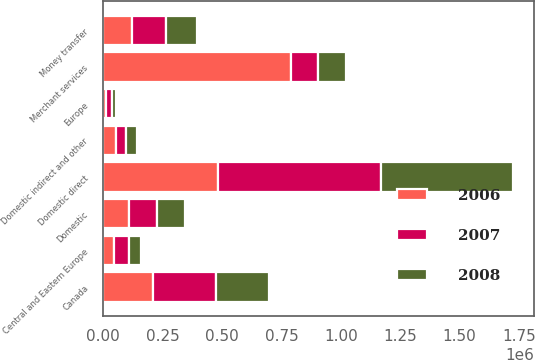<chart> <loc_0><loc_0><loc_500><loc_500><stacked_bar_chart><ecel><fcel>Domestic direct<fcel>Canada<fcel>Central and Eastern Europe<fcel>Domestic indirect and other<fcel>Merchant services<fcel>Domestic<fcel>Europe<fcel>Money transfer<nl><fcel>2007<fcel>687065<fcel>267249<fcel>59778<fcel>44150<fcel>117218<fcel>119019<fcel>24601<fcel>143620<nl><fcel>2008<fcel>558026<fcel>224570<fcel>51224<fcel>46873<fcel>117218<fcel>115416<fcel>16965<fcel>132381<nl><fcel>2006<fcel>481273<fcel>208126<fcel>47114<fcel>51987<fcel>788500<fcel>109067<fcel>10489<fcel>119556<nl></chart> 